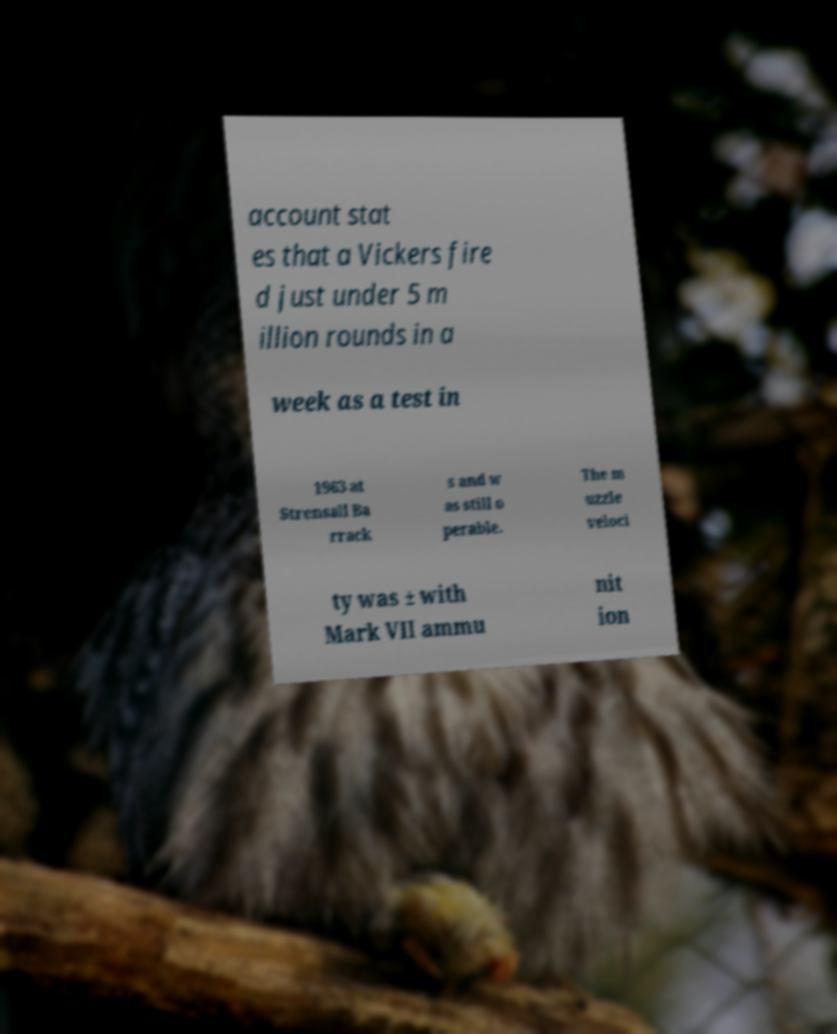Could you extract and type out the text from this image? account stat es that a Vickers fire d just under 5 m illion rounds in a week as a test in 1963 at Strensall Ba rrack s and w as still o perable. The m uzzle veloci ty was ± with Mark VII ammu nit ion 